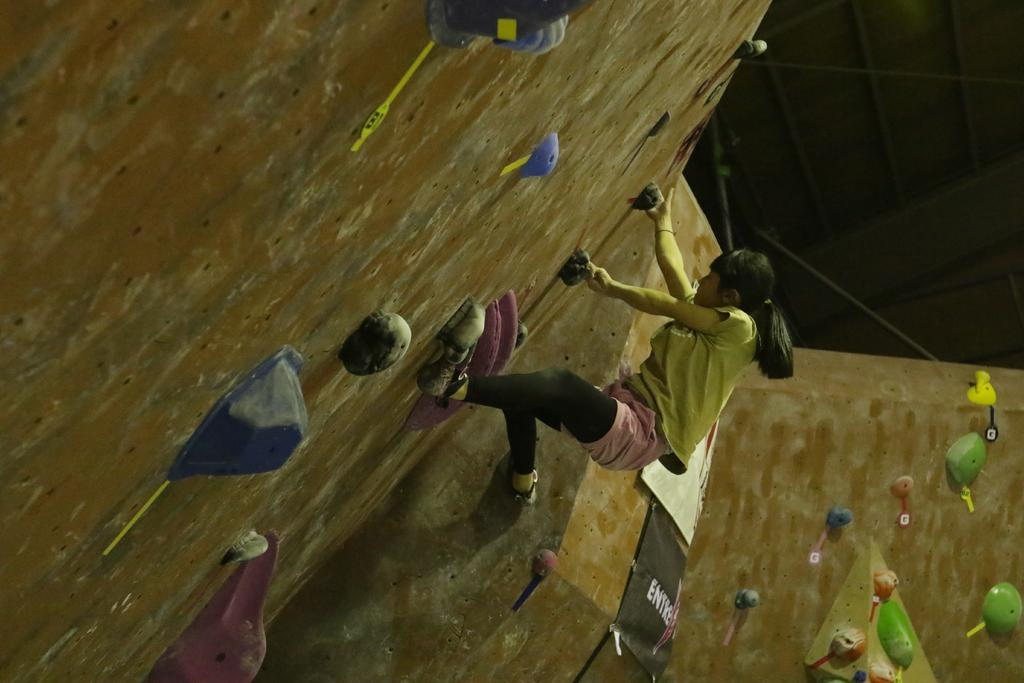Who is the main subject in the image? There is a woman in the image. What is the woman wearing? The woman is wearing a t-shirt. What activity is the woman engaged in? The woman is climbing a hill. What is the color of the background in the image? The background of the image is dark in color. Can you see a crown on the woman's head in the image? No, there is no crown visible on the woman's head in the image. What type of pen is the woman holding while climbing the hill? There is no pen present in the image; the woman is not holding any writing instrument. 